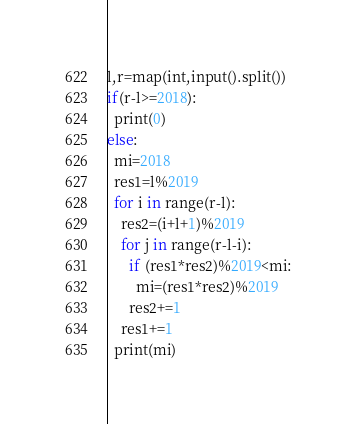<code> <loc_0><loc_0><loc_500><loc_500><_Python_>l,r=map(int,input().split())
if(r-l>=2018):
  print(0)
else:
  mi=2018
  res1=l%2019
  for i in range(r-l):
    res2=(i+l+1)%2019
    for j in range(r-l-i):
      if (res1*res2)%2019<mi:
        mi=(res1*res2)%2019
      res2+=1
    res1+=1
  print(mi)</code> 